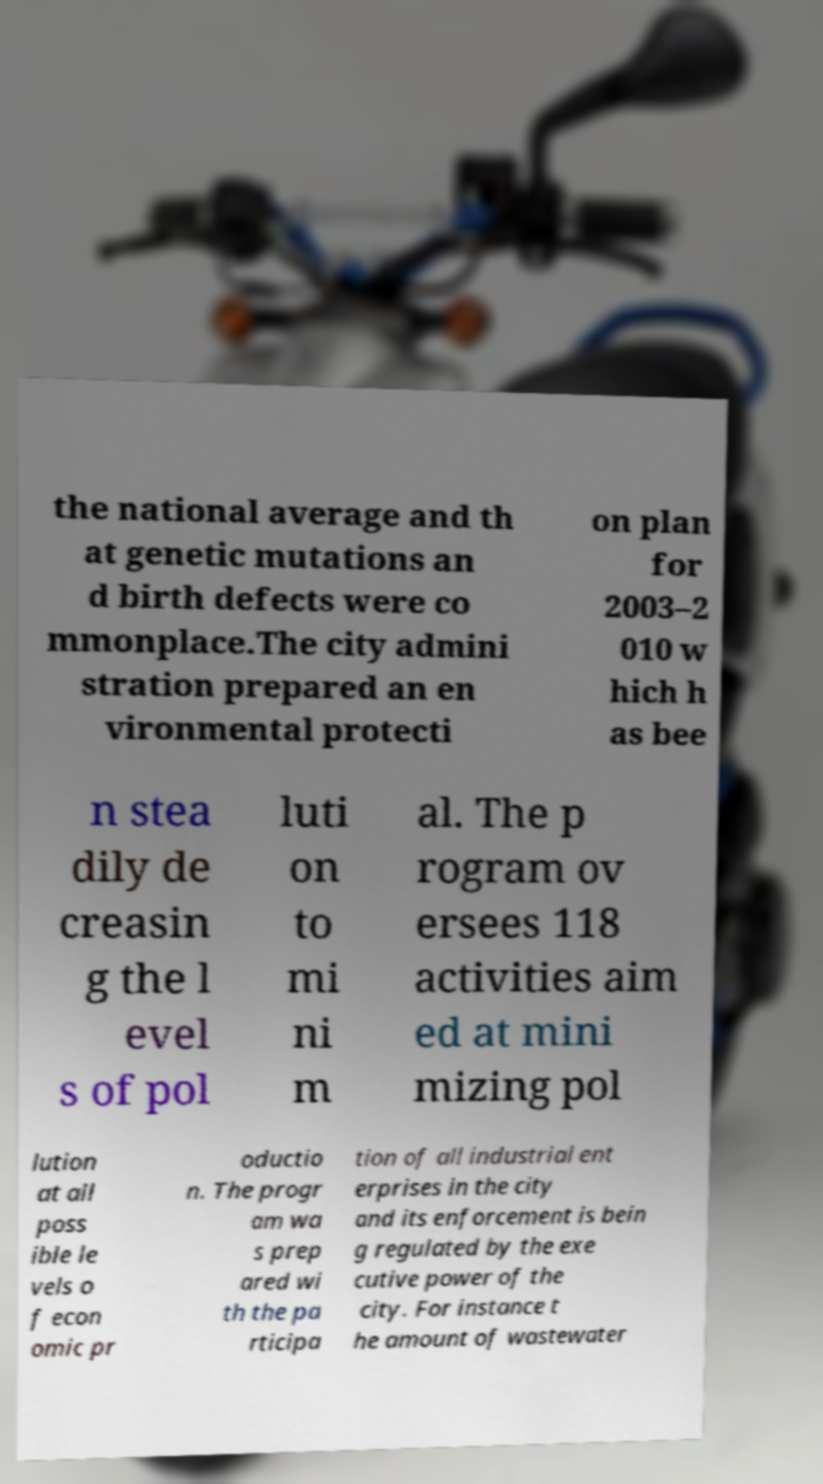Please identify and transcribe the text found in this image. the national average and th at genetic mutations an d birth defects were co mmonplace.The city admini stration prepared an en vironmental protecti on plan for 2003–2 010 w hich h as bee n stea dily de creasin g the l evel s of pol luti on to mi ni m al. The p rogram ov ersees 118 activities aim ed at mini mizing pol lution at all poss ible le vels o f econ omic pr oductio n. The progr am wa s prep ared wi th the pa rticipa tion of all industrial ent erprises in the city and its enforcement is bein g regulated by the exe cutive power of the city. For instance t he amount of wastewater 